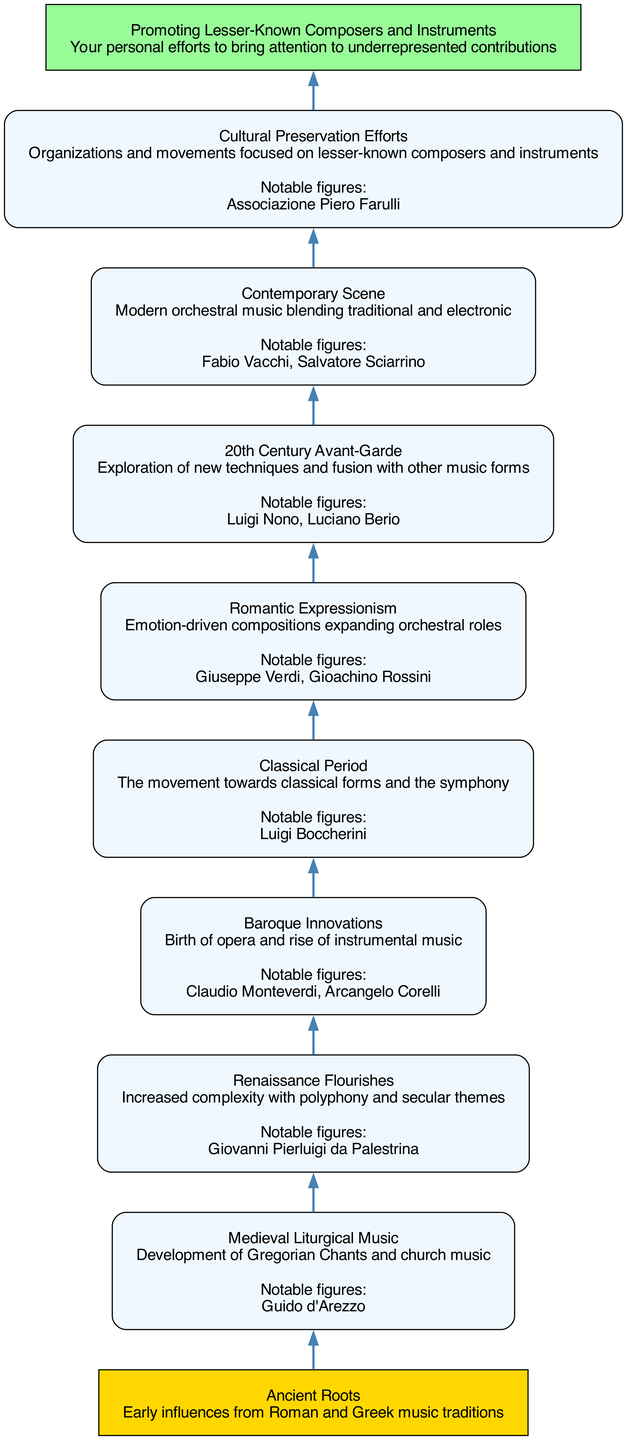What is the first element in the flow chart? The flow chart starts with "Ancient Roots," which is the first node representing early influences from Roman and Greek music traditions. This is confirmed by its position at the bottom of the diagram.
Answer: Ancient Roots Which composer is associated with Medieval Liturgical Music? The node for "Medieval Liturgical Music" lists "Guido d'Arezzo" as a related composer. This can be found directly in the description section of that particular node in the diagram.
Answer: Guido d'Arezzo How many nodes are there in the flow chart? By examining the number of elements specified in the provided data, there are a total of ten nodes, which is confirmed as the nodes correspond directly to each entry in the elements list.
Answer: 10 What period introduced the birth of opera? The "Baroque Innovations" node describes the birth of opera and rise of instrumental music. This information is explicitly stated in the description found under that particular node.
Answer: Baroque Innovations Which node represents your personal efforts? The last node, titled "Promoting Lesser-Known Composers and Instruments," signifies your personal efforts. As it is the final node in the upward flow, it indicates the culmination of the evolution discussed in the chart.
Answer: Promoting Lesser-Known Composers and Instruments Which two composers are linked to Romantic Expressionism? In the "Romantic Expressionism" node, the associated composers "Giuseppe Verdi" and "Gioachino Rossini" are explicitly mentioned under the notable figures section of that node. This can be confirmed by reviewing the composers listed in that particular node.
Answer: Giuseppe Verdi, Gioachino Rossini What transition does the diagram illustrate from the Baroque to Classical Period? The diagram illustrates a progression from "Baroque Innovations," which focuses on opera and instrumental music, to the "Classical Period," which emphasizes classical forms and the symphony. This relationship shows the shift in musical focus depicted in the diagram.
Answer: Transition from opera to classical forms In which part of the chart is "Cultural Preservation Efforts" located? The "Cultural Preservation Efforts" node is positioned directly above the contemporary developments, indicating an upward movement in the evolutionary journey of orchestral music in Italian culture. This can be traced through the arrangement of the overall flow.
Answer: Above the Contemporary Scene What is the significance of the "20th Century Avant-Garde"? The "20th Century Avant-Garde" represents the exploration of new techniques and fusion with various music forms, highlighting a significant shift in orchestral music's evolution. This is detailed in the description within that specific node.
Answer: Exploration of new techniques and fusion 